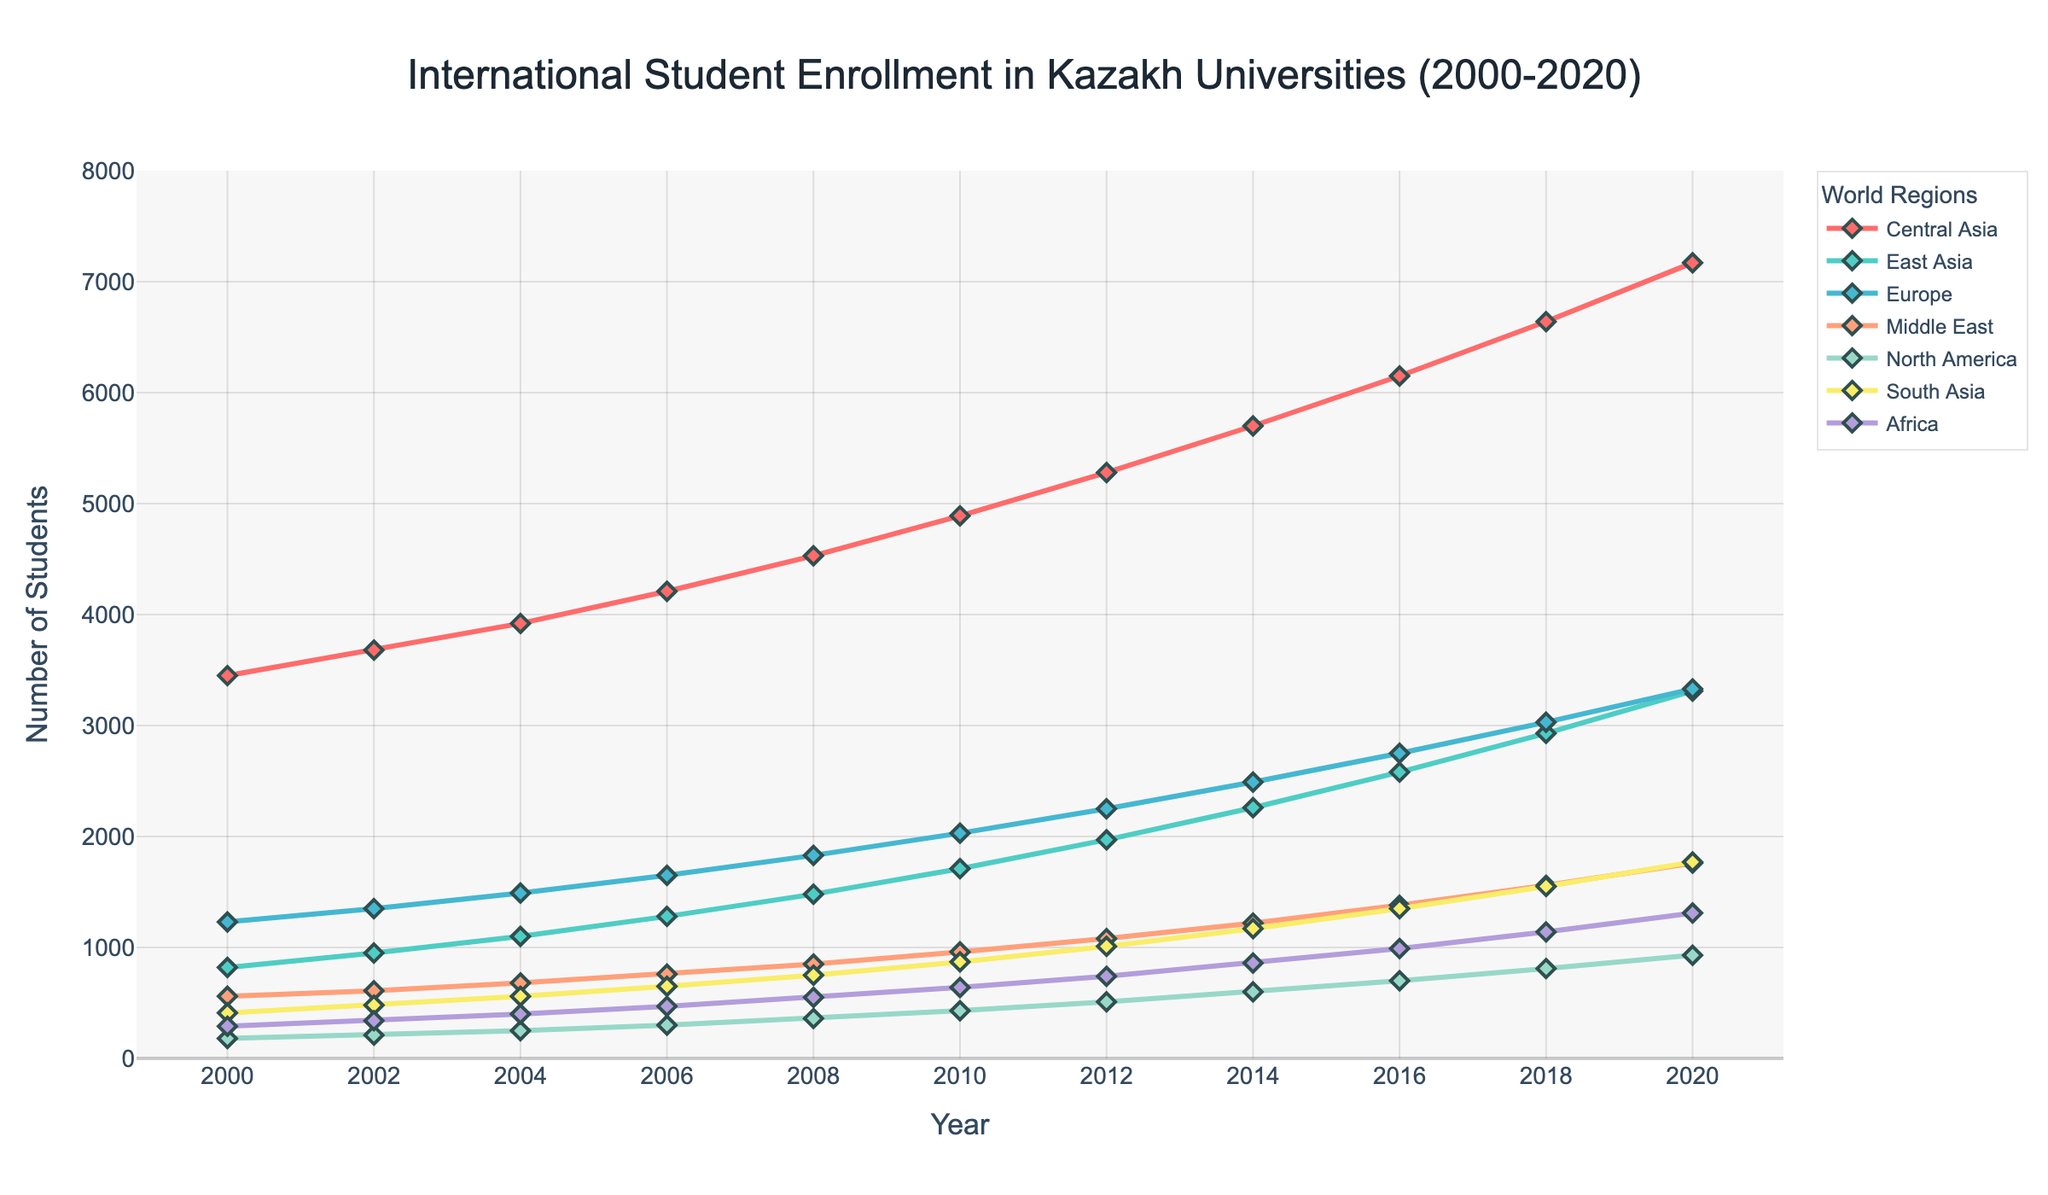What is the trend in the number of international students from Central Asia from 2000 to 2020? Over the years 2000 to 2020, the number of international students from Central Asia consistently increases each year, starting at 3450 in 2000 and ending at 7170 in 2020.
Answer: Consistent increase Which region had the highest number of students enrolled in 2014? In 2014, the region with the highest enrollment is Central Asia with 5700 students. This is evident by comparing the data points across all regions for the year 2014.
Answer: Central Asia What is the difference in the number of students from North America between 2016 and 2020? In 2016, there were 700 North American students, and in 2020, there were 930. The difference is calculated as 930 - 700 = 230.
Answer: 230 Which region shows the most rapid increase in student numbers between 2000 and 2020? To determine the most rapid increase, we should look at the initial and final values for each region and calculate the difference. The most significant increase is seen in Central Asia, which increased by (7170 - 3450) = 3720 students.
Answer: Central Asia How does the number of students from East Asia in 2010 compare to Europe in 2012? In 2010, the number of students from East Asia is 1710. In 2012, the number of students from Europe is 2250. Comparing these values shows that Europe had more students in 2012 than East Asia in 2010.
Answer: Europe had more What is the average number of students from Africa over the given period? To find the average, sum the number of students from Africa for all years and divide by the number of years. (290 + 340 + 400 + 470 + 550 + 640 + 740 + 860 + 990 + 1140 + 1310) = 8730; 8730 / 11 ≈ 793.64
Answer: 793.64 In which year did South Asia surpass 1500 students, and by how many students did it surpass this threshold? Looking at the trend for South Asia, in 2018 the number of students was 1550, which surpasses 1500. The number surpassed is 1550 - 1500 = 50.
Answer: 2018, by 50 What was the lowest enrollment recorded in 2000, and from which region? In 2000, the lowest recorded enrollment is from North America with 180 students. This can be seen by comparing all regional values for the year 2000.
Answer: 180, North America By how much did the student enrollment from the Middle East increase from 2002 to 2008? In 2002, the enrollment from the Middle East is 610. In 2008, it is 850. The increase is calculated as 850 - 610 = 240.
Answer: 240 